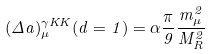<formula> <loc_0><loc_0><loc_500><loc_500>( \Delta a ) _ { \mu } ^ { \gamma K K } ( d = 1 ) = \alpha \frac { \pi } { 9 } \frac { m _ { \mu } ^ { 2 } } { M _ { R } ^ { 2 } }</formula> 